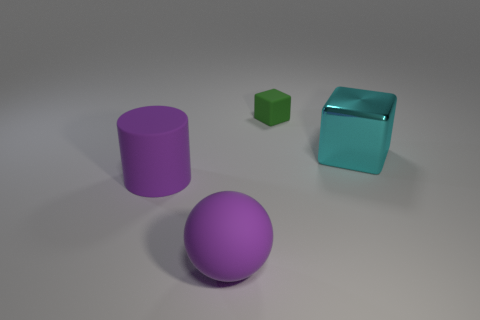Does the green object have the same material as the cyan object? The green and cyan objects appear to have different surface characteristics, indicating that they may not be made of the same material. The cyan object has a reflective surface suggesting it might be metallic or plastic, whereas the green object seems to have a matte finish, which could imply a different composition, such as painted wood or another non-reflective material. 